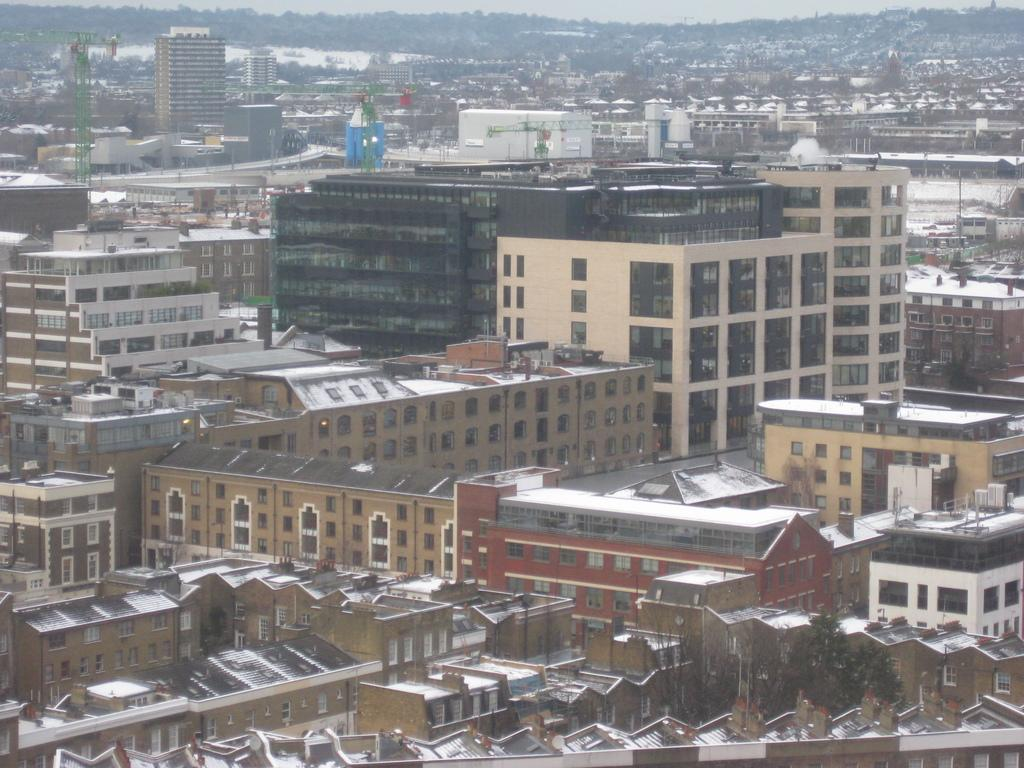What type of weather condition is depicted in the image? There is snow on the buildings and roofs, indicating a snowy weather condition. What type of structures can be seen in the image? There are houses and buildings in the image. What type of construction equipment is present in the image? Cranes are present in the image. What type of vegetation is visible in the image? Trees are visible in the image. What type of architectural feature is present in the image? Glass doors are present in the image. What type of openings are visible in the structures? Windows are visible in the image. What part of the natural environment is visible in the image? The sky is visible in the image. What type of credit card is being used to purchase the house in the image? There is no indication of a house being purchased or a credit card being used in the image. 